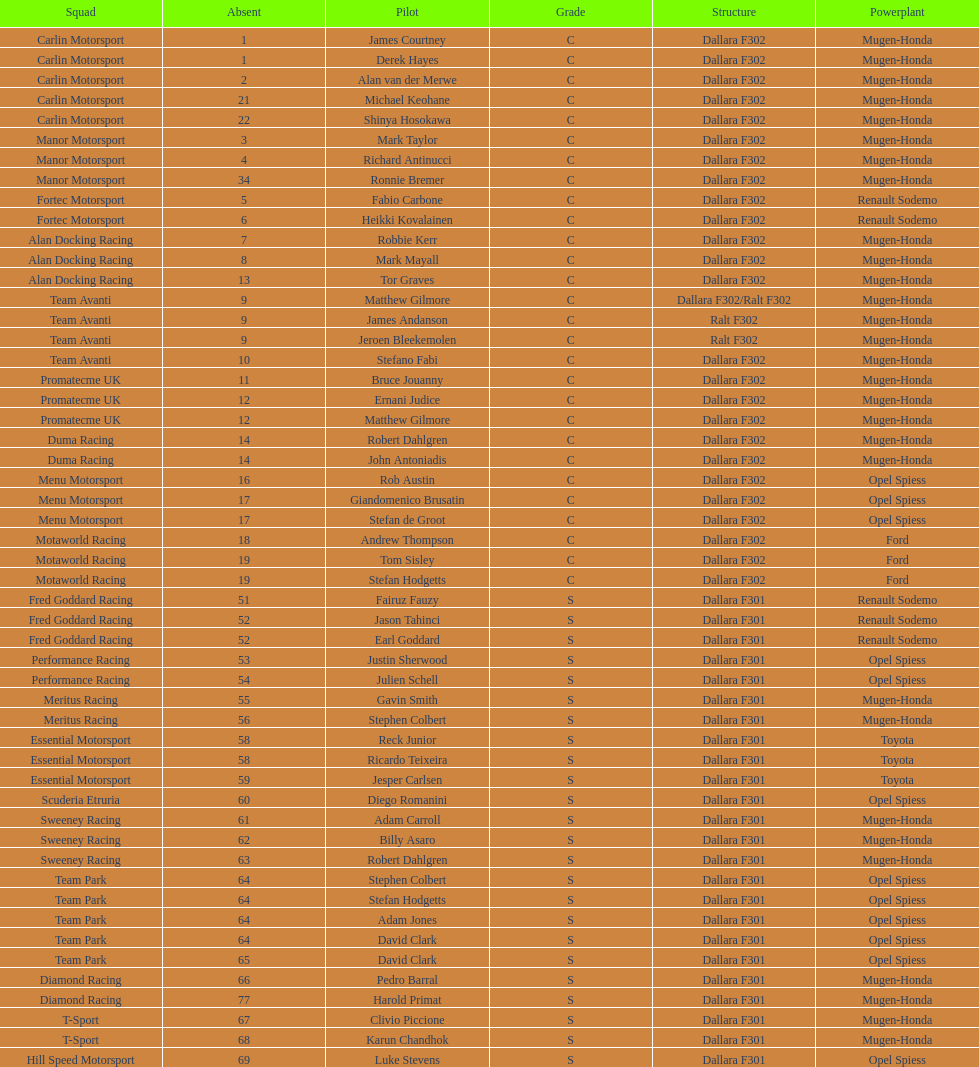What is the number of teams that had drivers all from the same country? 4. 